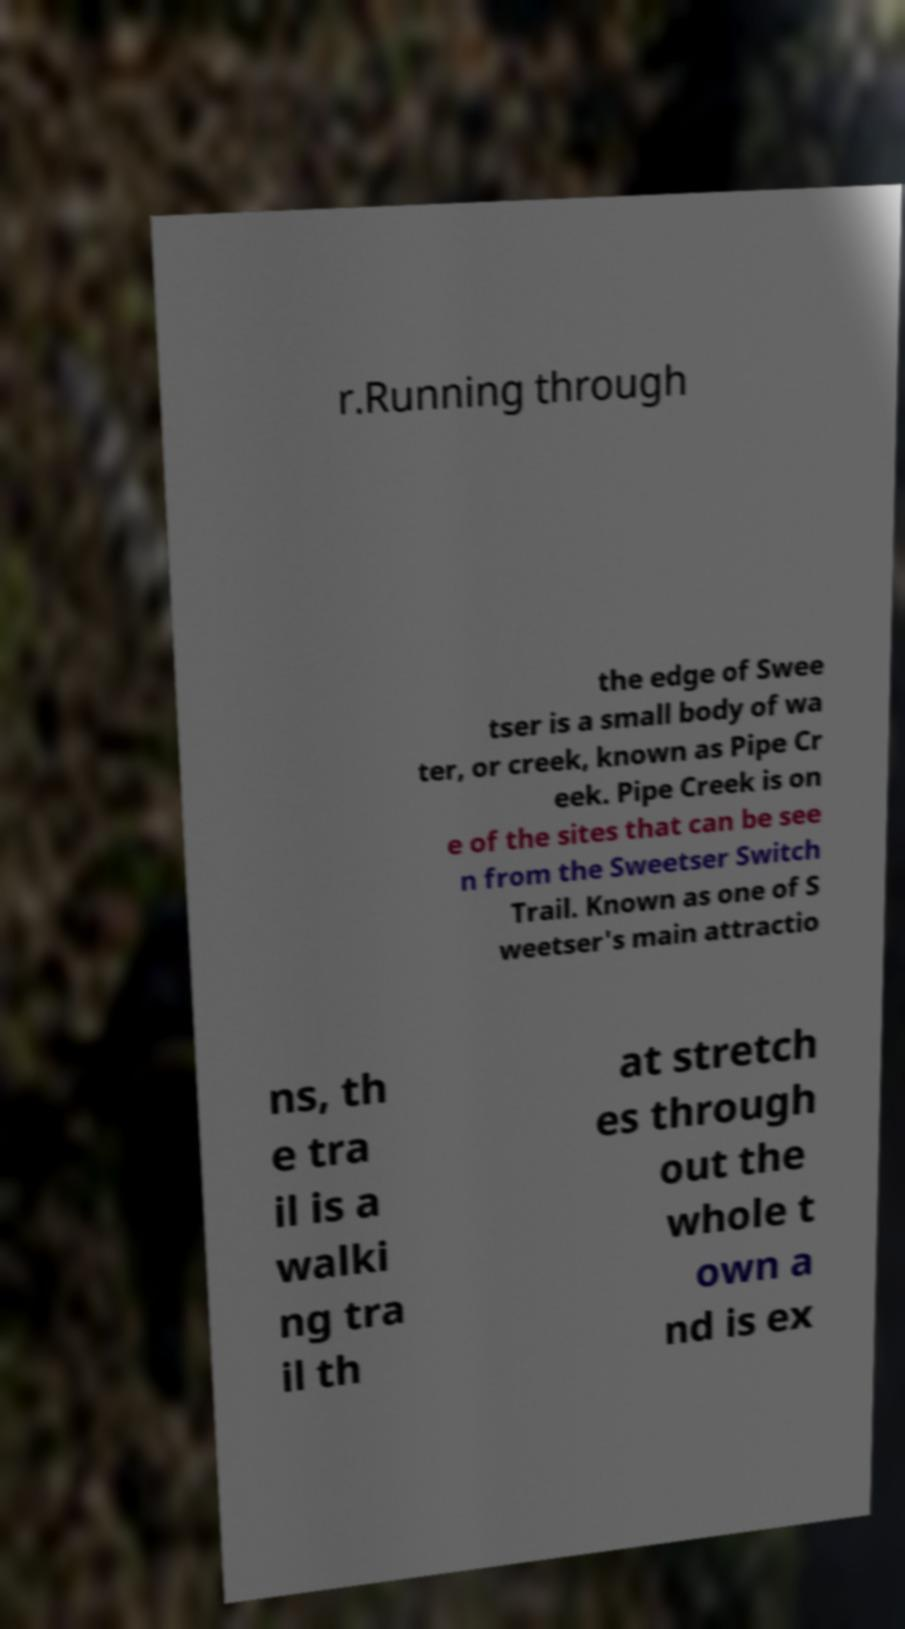Please read and relay the text visible in this image. What does it say? r.Running through the edge of Swee tser is a small body of wa ter, or creek, known as Pipe Cr eek. Pipe Creek is on e of the sites that can be see n from the Sweetser Switch Trail. Known as one of S weetser's main attractio ns, th e tra il is a walki ng tra il th at stretch es through out the whole t own a nd is ex 